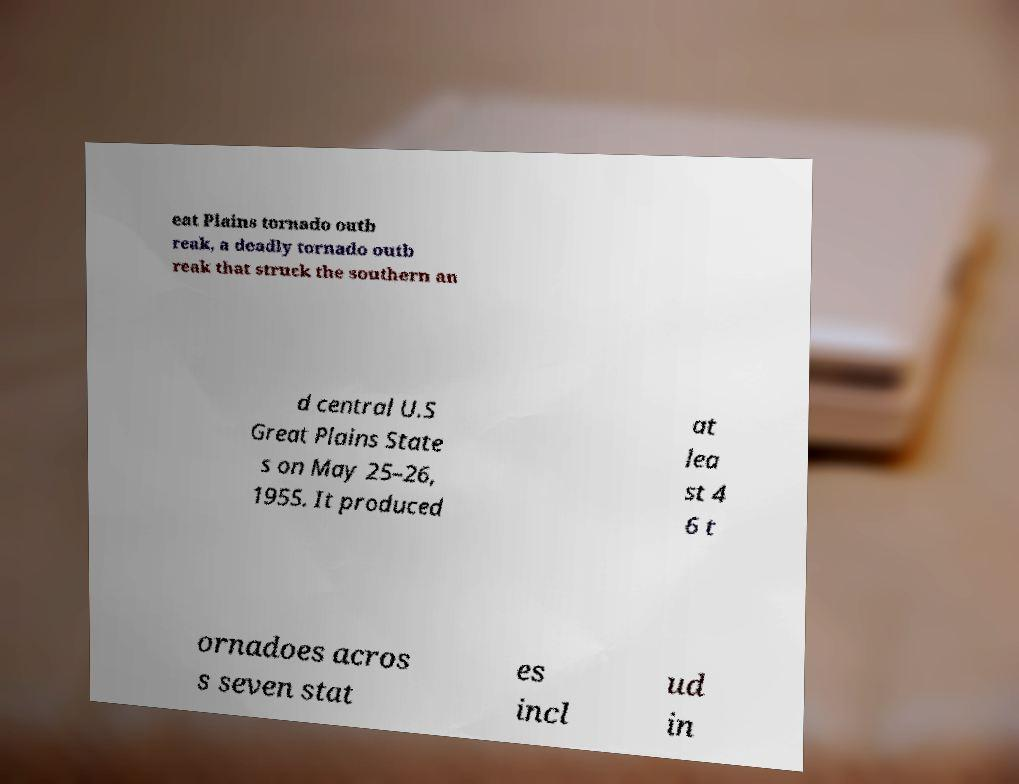Can you read and provide the text displayed in the image?This photo seems to have some interesting text. Can you extract and type it out for me? eat Plains tornado outb reak, a deadly tornado outb reak that struck the southern an d central U.S Great Plains State s on May 25–26, 1955. It produced at lea st 4 6 t ornadoes acros s seven stat es incl ud in 